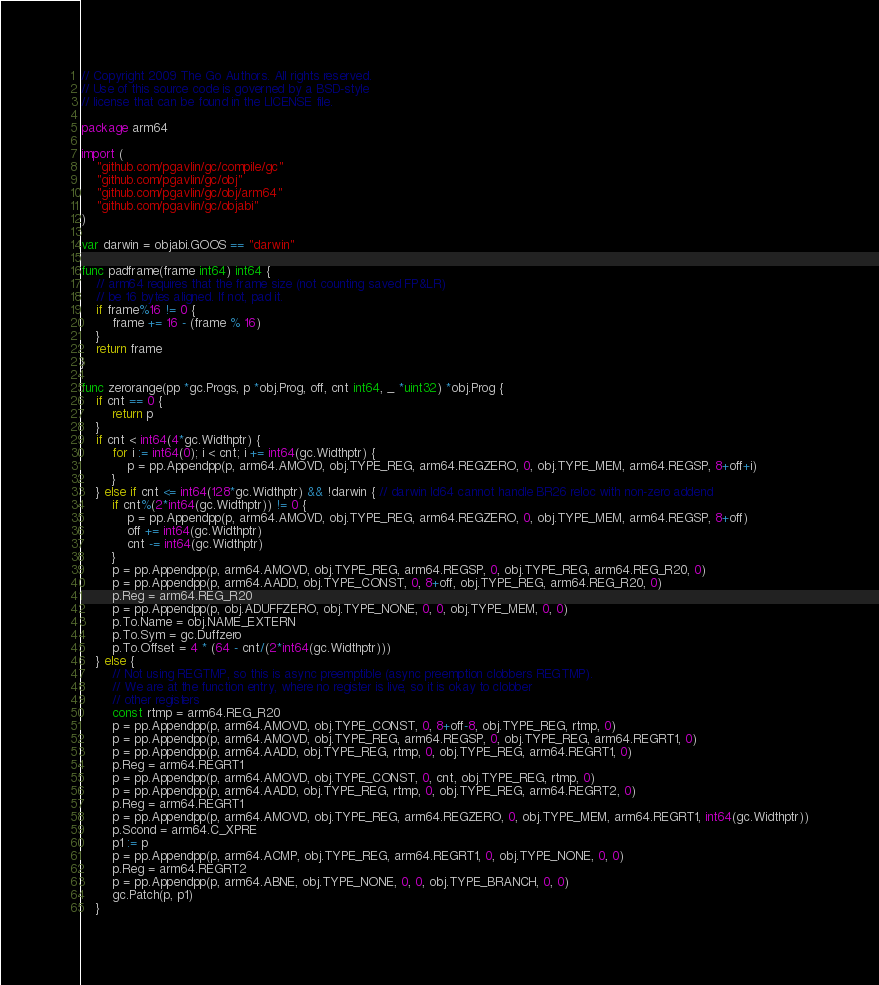<code> <loc_0><loc_0><loc_500><loc_500><_Go_>// Copyright 2009 The Go Authors. All rights reserved.
// Use of this source code is governed by a BSD-style
// license that can be found in the LICENSE file.

package arm64

import (
	"github.com/pgavlin/gc/compile/gc"
	"github.com/pgavlin/gc/obj"
	"github.com/pgavlin/gc/obj/arm64"
	"github.com/pgavlin/gc/objabi"
)

var darwin = objabi.GOOS == "darwin"

func padframe(frame int64) int64 {
	// arm64 requires that the frame size (not counting saved FP&LR)
	// be 16 bytes aligned. If not, pad it.
	if frame%16 != 0 {
		frame += 16 - (frame % 16)
	}
	return frame
}

func zerorange(pp *gc.Progs, p *obj.Prog, off, cnt int64, _ *uint32) *obj.Prog {
	if cnt == 0 {
		return p
	}
	if cnt < int64(4*gc.Widthptr) {
		for i := int64(0); i < cnt; i += int64(gc.Widthptr) {
			p = pp.Appendpp(p, arm64.AMOVD, obj.TYPE_REG, arm64.REGZERO, 0, obj.TYPE_MEM, arm64.REGSP, 8+off+i)
		}
	} else if cnt <= int64(128*gc.Widthptr) && !darwin { // darwin ld64 cannot handle BR26 reloc with non-zero addend
		if cnt%(2*int64(gc.Widthptr)) != 0 {
			p = pp.Appendpp(p, arm64.AMOVD, obj.TYPE_REG, arm64.REGZERO, 0, obj.TYPE_MEM, arm64.REGSP, 8+off)
			off += int64(gc.Widthptr)
			cnt -= int64(gc.Widthptr)
		}
		p = pp.Appendpp(p, arm64.AMOVD, obj.TYPE_REG, arm64.REGSP, 0, obj.TYPE_REG, arm64.REG_R20, 0)
		p = pp.Appendpp(p, arm64.AADD, obj.TYPE_CONST, 0, 8+off, obj.TYPE_REG, arm64.REG_R20, 0)
		p.Reg = arm64.REG_R20
		p = pp.Appendpp(p, obj.ADUFFZERO, obj.TYPE_NONE, 0, 0, obj.TYPE_MEM, 0, 0)
		p.To.Name = obj.NAME_EXTERN
		p.To.Sym = gc.Duffzero
		p.To.Offset = 4 * (64 - cnt/(2*int64(gc.Widthptr)))
	} else {
		// Not using REGTMP, so this is async preemptible (async preemption clobbers REGTMP).
		// We are at the function entry, where no register is live, so it is okay to clobber
		// other registers
		const rtmp = arm64.REG_R20
		p = pp.Appendpp(p, arm64.AMOVD, obj.TYPE_CONST, 0, 8+off-8, obj.TYPE_REG, rtmp, 0)
		p = pp.Appendpp(p, arm64.AMOVD, obj.TYPE_REG, arm64.REGSP, 0, obj.TYPE_REG, arm64.REGRT1, 0)
		p = pp.Appendpp(p, arm64.AADD, obj.TYPE_REG, rtmp, 0, obj.TYPE_REG, arm64.REGRT1, 0)
		p.Reg = arm64.REGRT1
		p = pp.Appendpp(p, arm64.AMOVD, obj.TYPE_CONST, 0, cnt, obj.TYPE_REG, rtmp, 0)
		p = pp.Appendpp(p, arm64.AADD, obj.TYPE_REG, rtmp, 0, obj.TYPE_REG, arm64.REGRT2, 0)
		p.Reg = arm64.REGRT1
		p = pp.Appendpp(p, arm64.AMOVD, obj.TYPE_REG, arm64.REGZERO, 0, obj.TYPE_MEM, arm64.REGRT1, int64(gc.Widthptr))
		p.Scond = arm64.C_XPRE
		p1 := p
		p = pp.Appendpp(p, arm64.ACMP, obj.TYPE_REG, arm64.REGRT1, 0, obj.TYPE_NONE, 0, 0)
		p.Reg = arm64.REGRT2
		p = pp.Appendpp(p, arm64.ABNE, obj.TYPE_NONE, 0, 0, obj.TYPE_BRANCH, 0, 0)
		gc.Patch(p, p1)
	}
</code> 